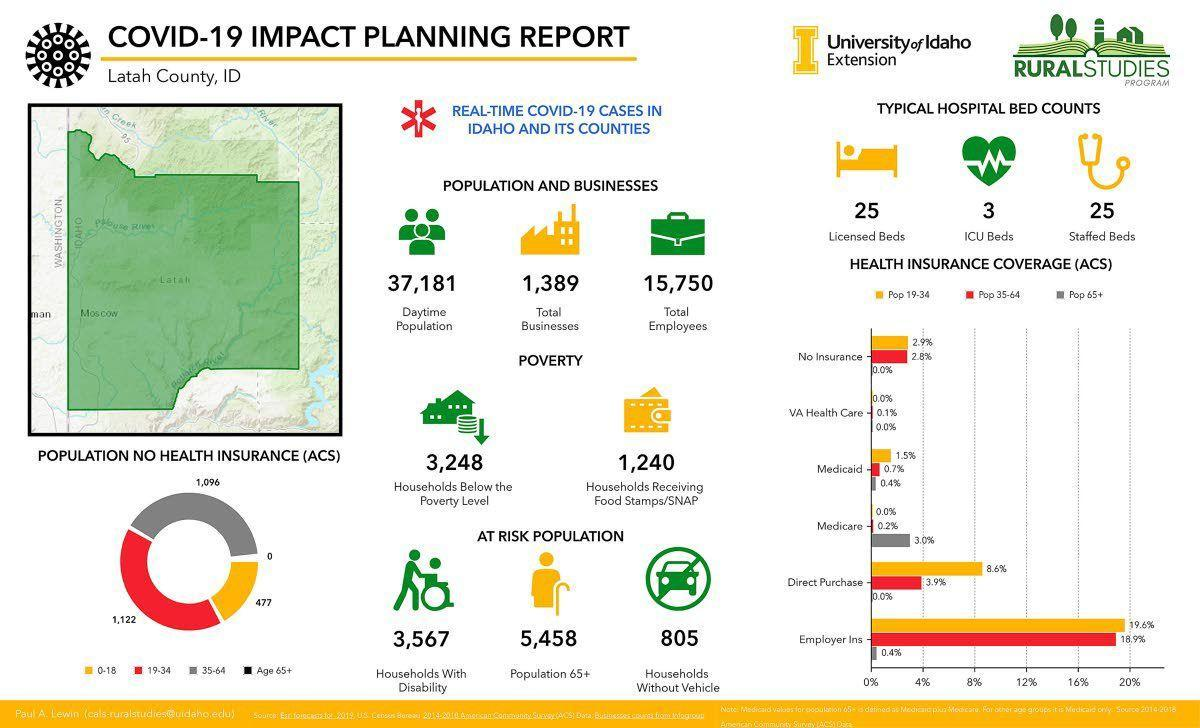Indicate a few pertinent items in this graphic. According to the latest statistics, approximately 0.7% of the population in the age group of 35-64 has Medicaid coverage. Only 3.0% of senior citizens have Medicaid, a government-funded health insurance program for low-income individuals. According to the data, 1,122 individuals reported having no health insurance, and they primarily belong to the age group of 19-34. There are 53 hospital beds in total, including licensed, ICU, and staffed beds. According to the data, only 8.6% of the population aged 19-34 purchase health insurance directly. 